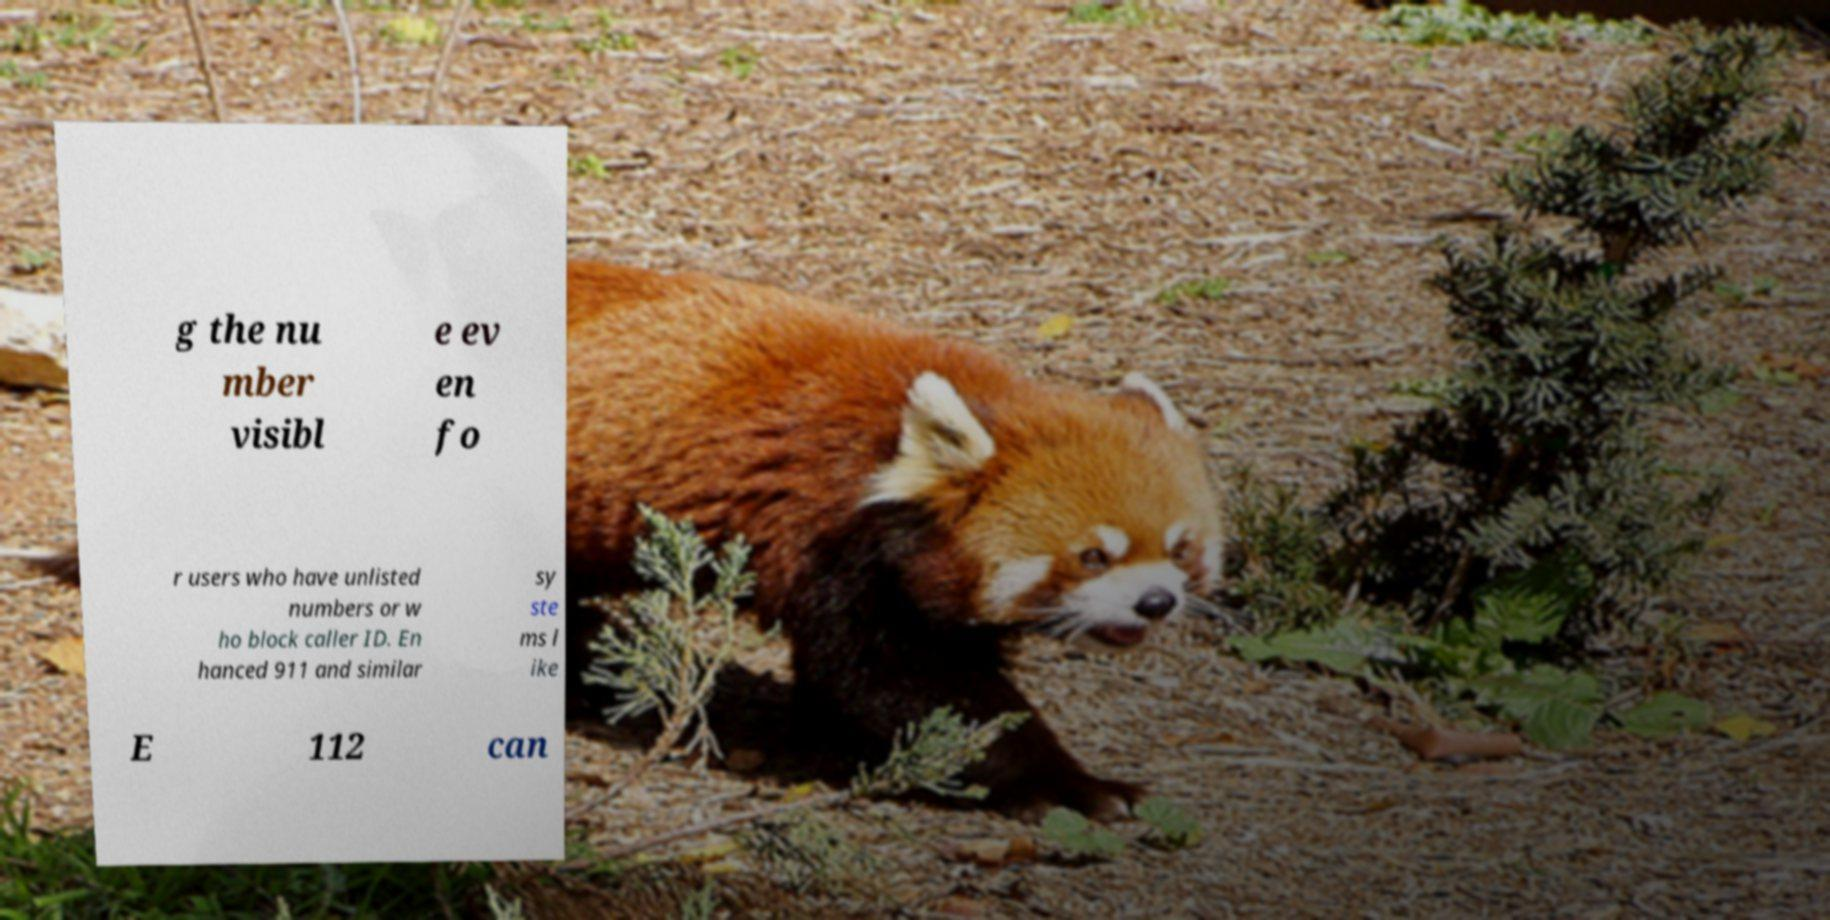Could you assist in decoding the text presented in this image and type it out clearly? g the nu mber visibl e ev en fo r users who have unlisted numbers or w ho block caller ID. En hanced 911 and similar sy ste ms l ike E 112 can 